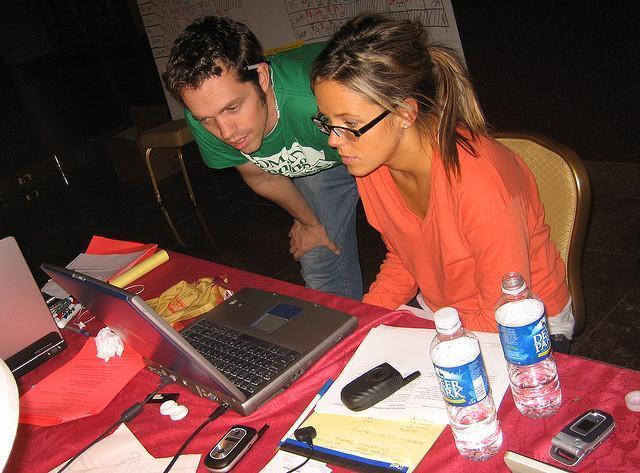How many cell phones are on the table?
Give a very brief answer. 3. How many asians are at the table?
Give a very brief answer. 0. How many blue bottles are on the table?
Give a very brief answer. 2. How many people are visible?
Give a very brief answer. 2. How many laptops are there?
Give a very brief answer. 2. How many bottles are in the photo?
Give a very brief answer. 2. How many chairs are in the photo?
Give a very brief answer. 2. 